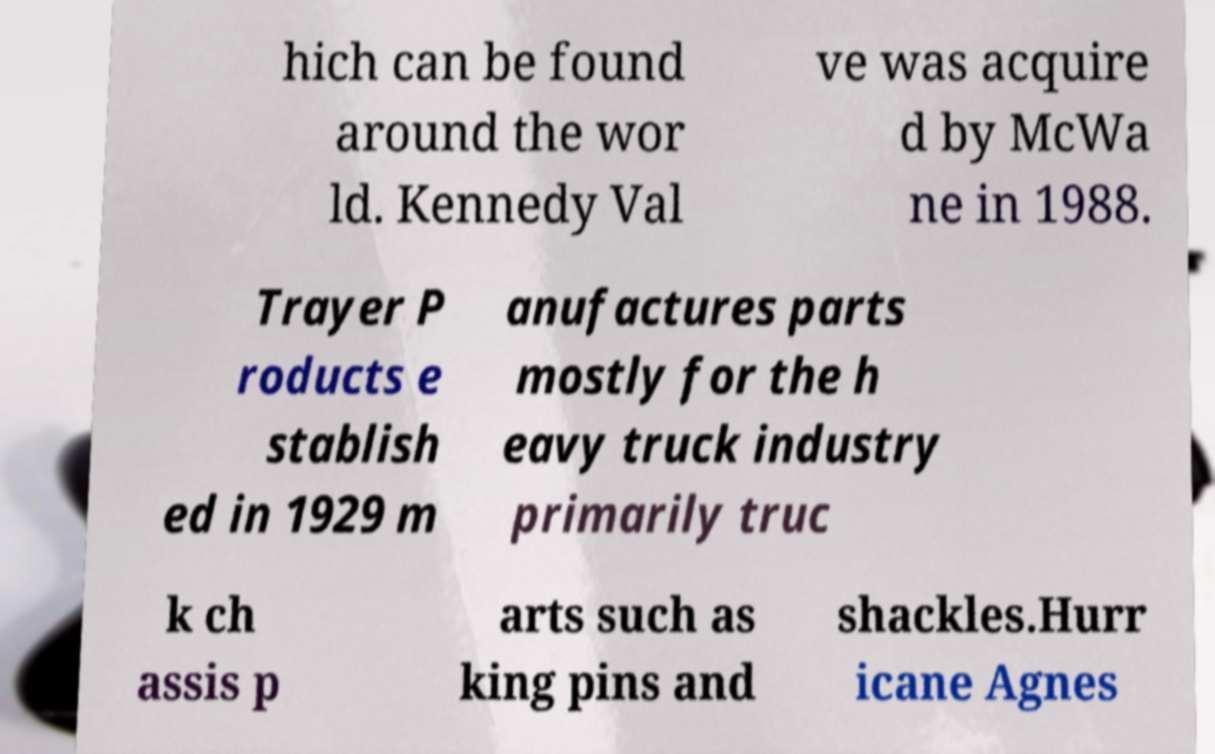Can you read and provide the text displayed in the image?This photo seems to have some interesting text. Can you extract and type it out for me? hich can be found around the wor ld. Kennedy Val ve was acquire d by McWa ne in 1988. Trayer P roducts e stablish ed in 1929 m anufactures parts mostly for the h eavy truck industry primarily truc k ch assis p arts such as king pins and shackles.Hurr icane Agnes 